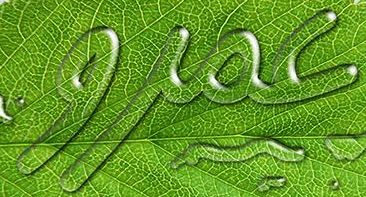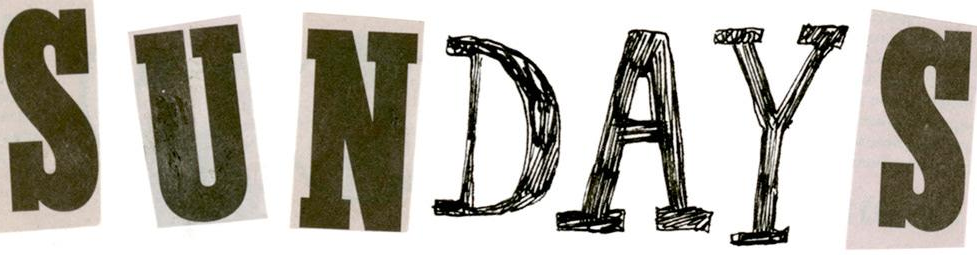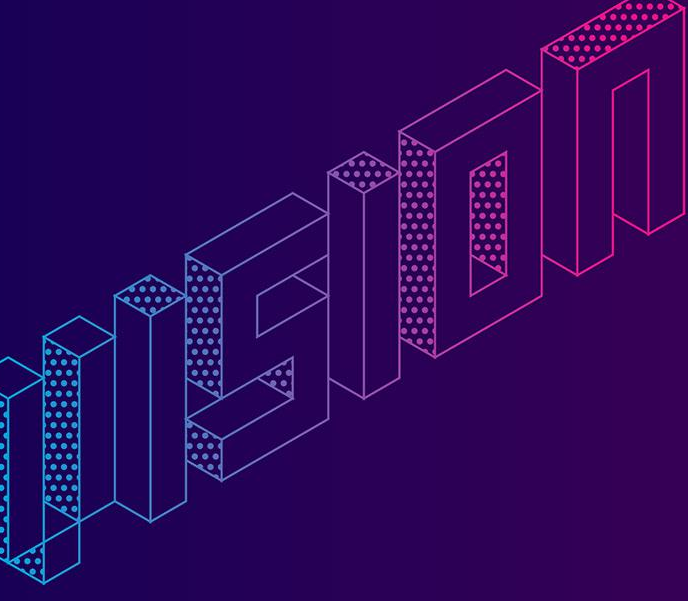What words can you see in these images in sequence, separated by a semicolon? jioc; SUNDAYS; VISION 